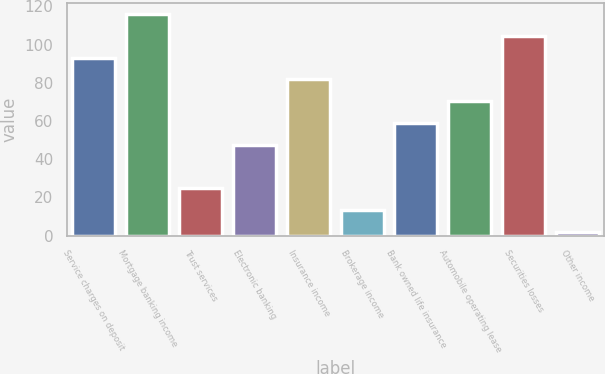Convert chart. <chart><loc_0><loc_0><loc_500><loc_500><bar_chart><fcel>Service charges on deposit<fcel>Mortgage banking income<fcel>Trust services<fcel>Electronic banking<fcel>Insurance income<fcel>Brokerage income<fcel>Bank owned life insurance<fcel>Automobile operating lease<fcel>Securities losses<fcel>Other income<nl><fcel>93.2<fcel>116<fcel>24.8<fcel>47.6<fcel>81.8<fcel>13.4<fcel>59<fcel>70.4<fcel>104.6<fcel>2<nl></chart> 